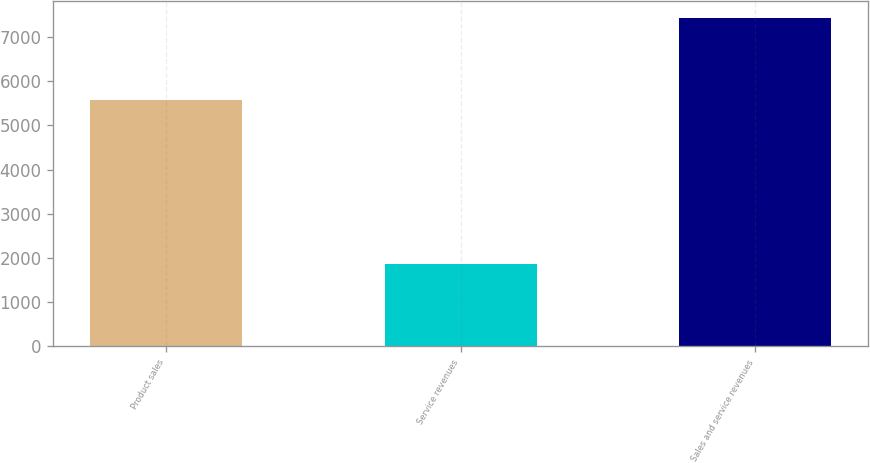Convert chart to OTSL. <chart><loc_0><loc_0><loc_500><loc_500><bar_chart><fcel>Product sales<fcel>Service revenues<fcel>Sales and service revenues<nl><fcel>5573<fcel>1868<fcel>7441<nl></chart> 